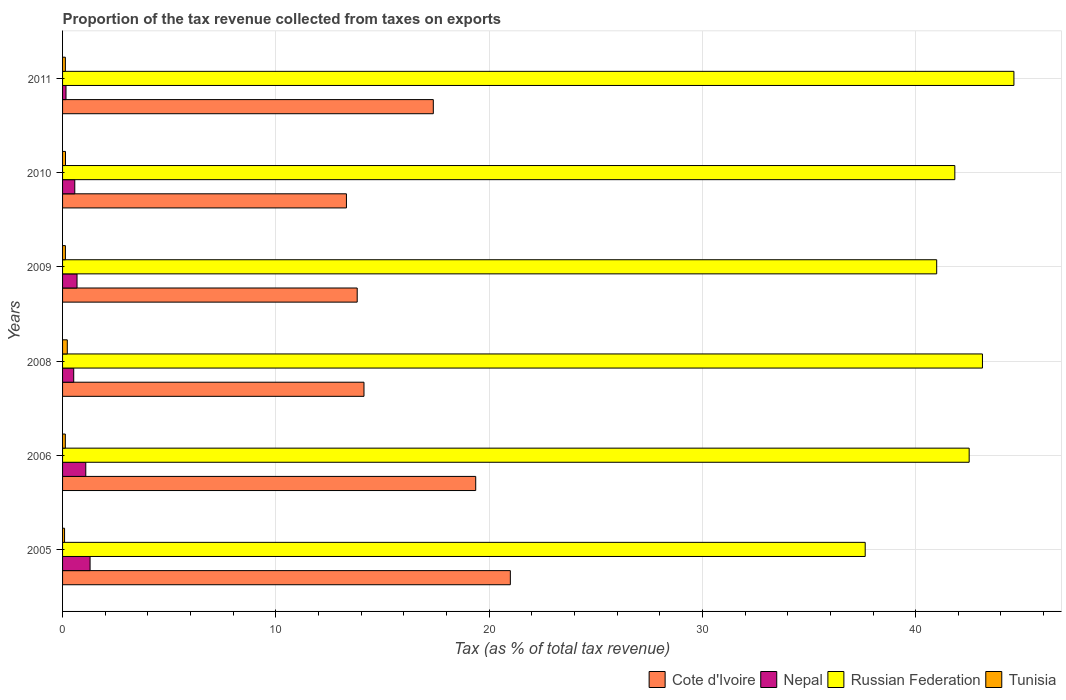How many different coloured bars are there?
Your answer should be compact. 4. How many groups of bars are there?
Your answer should be compact. 6. What is the label of the 3rd group of bars from the top?
Provide a succinct answer. 2009. What is the proportion of the tax revenue collected in Cote d'Ivoire in 2005?
Offer a very short reply. 21. Across all years, what is the maximum proportion of the tax revenue collected in Nepal?
Your answer should be compact. 1.29. Across all years, what is the minimum proportion of the tax revenue collected in Russian Federation?
Your answer should be compact. 37.63. What is the total proportion of the tax revenue collected in Tunisia in the graph?
Provide a short and direct response. 0.85. What is the difference between the proportion of the tax revenue collected in Russian Federation in 2005 and that in 2009?
Provide a succinct answer. -3.35. What is the difference between the proportion of the tax revenue collected in Nepal in 2005 and the proportion of the tax revenue collected in Cote d'Ivoire in 2009?
Offer a very short reply. -12.52. What is the average proportion of the tax revenue collected in Nepal per year?
Your answer should be compact. 0.72. In the year 2011, what is the difference between the proportion of the tax revenue collected in Russian Federation and proportion of the tax revenue collected in Tunisia?
Offer a terse response. 44.48. In how many years, is the proportion of the tax revenue collected in Russian Federation greater than 16 %?
Your answer should be compact. 6. What is the ratio of the proportion of the tax revenue collected in Russian Federation in 2005 to that in 2009?
Ensure brevity in your answer.  0.92. Is the proportion of the tax revenue collected in Nepal in 2008 less than that in 2011?
Make the answer very short. No. What is the difference between the highest and the second highest proportion of the tax revenue collected in Cote d'Ivoire?
Give a very brief answer. 1.62. What is the difference between the highest and the lowest proportion of the tax revenue collected in Tunisia?
Offer a very short reply. 0.13. In how many years, is the proportion of the tax revenue collected in Tunisia greater than the average proportion of the tax revenue collected in Tunisia taken over all years?
Provide a short and direct response. 1. Is it the case that in every year, the sum of the proportion of the tax revenue collected in Cote d'Ivoire and proportion of the tax revenue collected in Russian Federation is greater than the sum of proportion of the tax revenue collected in Nepal and proportion of the tax revenue collected in Tunisia?
Offer a terse response. Yes. What does the 4th bar from the top in 2010 represents?
Make the answer very short. Cote d'Ivoire. What does the 4th bar from the bottom in 2009 represents?
Make the answer very short. Tunisia. How many years are there in the graph?
Your answer should be compact. 6. What is the difference between two consecutive major ticks on the X-axis?
Keep it short and to the point. 10. Are the values on the major ticks of X-axis written in scientific E-notation?
Your response must be concise. No. Does the graph contain grids?
Give a very brief answer. Yes. What is the title of the graph?
Keep it short and to the point. Proportion of the tax revenue collected from taxes on exports. What is the label or title of the X-axis?
Make the answer very short. Tax (as % of total tax revenue). What is the Tax (as % of total tax revenue) in Cote d'Ivoire in 2005?
Your answer should be compact. 21. What is the Tax (as % of total tax revenue) in Nepal in 2005?
Offer a very short reply. 1.29. What is the Tax (as % of total tax revenue) in Russian Federation in 2005?
Your response must be concise. 37.63. What is the Tax (as % of total tax revenue) in Tunisia in 2005?
Ensure brevity in your answer.  0.09. What is the Tax (as % of total tax revenue) in Cote d'Ivoire in 2006?
Your answer should be compact. 19.37. What is the Tax (as % of total tax revenue) of Nepal in 2006?
Provide a succinct answer. 1.09. What is the Tax (as % of total tax revenue) in Russian Federation in 2006?
Your answer should be compact. 42.51. What is the Tax (as % of total tax revenue) of Tunisia in 2006?
Your response must be concise. 0.13. What is the Tax (as % of total tax revenue) of Cote d'Ivoire in 2008?
Your response must be concise. 14.13. What is the Tax (as % of total tax revenue) in Nepal in 2008?
Give a very brief answer. 0.52. What is the Tax (as % of total tax revenue) in Russian Federation in 2008?
Keep it short and to the point. 43.13. What is the Tax (as % of total tax revenue) of Tunisia in 2008?
Your response must be concise. 0.22. What is the Tax (as % of total tax revenue) in Cote d'Ivoire in 2009?
Keep it short and to the point. 13.81. What is the Tax (as % of total tax revenue) in Nepal in 2009?
Your answer should be very brief. 0.68. What is the Tax (as % of total tax revenue) in Russian Federation in 2009?
Make the answer very short. 40.99. What is the Tax (as % of total tax revenue) of Tunisia in 2009?
Keep it short and to the point. 0.13. What is the Tax (as % of total tax revenue) in Cote d'Ivoire in 2010?
Make the answer very short. 13.31. What is the Tax (as % of total tax revenue) in Nepal in 2010?
Offer a terse response. 0.57. What is the Tax (as % of total tax revenue) of Russian Federation in 2010?
Your answer should be very brief. 41.84. What is the Tax (as % of total tax revenue) in Tunisia in 2010?
Keep it short and to the point. 0.14. What is the Tax (as % of total tax revenue) of Cote d'Ivoire in 2011?
Ensure brevity in your answer.  17.38. What is the Tax (as % of total tax revenue) in Nepal in 2011?
Your answer should be very brief. 0.16. What is the Tax (as % of total tax revenue) of Russian Federation in 2011?
Ensure brevity in your answer.  44.61. What is the Tax (as % of total tax revenue) of Tunisia in 2011?
Offer a terse response. 0.13. Across all years, what is the maximum Tax (as % of total tax revenue) of Cote d'Ivoire?
Your answer should be compact. 21. Across all years, what is the maximum Tax (as % of total tax revenue) of Nepal?
Make the answer very short. 1.29. Across all years, what is the maximum Tax (as % of total tax revenue) in Russian Federation?
Your answer should be compact. 44.61. Across all years, what is the maximum Tax (as % of total tax revenue) of Tunisia?
Provide a succinct answer. 0.22. Across all years, what is the minimum Tax (as % of total tax revenue) in Cote d'Ivoire?
Give a very brief answer. 13.31. Across all years, what is the minimum Tax (as % of total tax revenue) of Nepal?
Keep it short and to the point. 0.16. Across all years, what is the minimum Tax (as % of total tax revenue) in Russian Federation?
Your response must be concise. 37.63. Across all years, what is the minimum Tax (as % of total tax revenue) of Tunisia?
Keep it short and to the point. 0.09. What is the total Tax (as % of total tax revenue) in Cote d'Ivoire in the graph?
Provide a short and direct response. 99.01. What is the total Tax (as % of total tax revenue) in Nepal in the graph?
Your response must be concise. 4.31. What is the total Tax (as % of total tax revenue) of Russian Federation in the graph?
Provide a short and direct response. 250.71. What is the total Tax (as % of total tax revenue) of Tunisia in the graph?
Give a very brief answer. 0.85. What is the difference between the Tax (as % of total tax revenue) in Cote d'Ivoire in 2005 and that in 2006?
Provide a succinct answer. 1.62. What is the difference between the Tax (as % of total tax revenue) in Nepal in 2005 and that in 2006?
Ensure brevity in your answer.  0.2. What is the difference between the Tax (as % of total tax revenue) in Russian Federation in 2005 and that in 2006?
Keep it short and to the point. -4.87. What is the difference between the Tax (as % of total tax revenue) in Tunisia in 2005 and that in 2006?
Your answer should be very brief. -0.04. What is the difference between the Tax (as % of total tax revenue) of Cote d'Ivoire in 2005 and that in 2008?
Offer a terse response. 6.86. What is the difference between the Tax (as % of total tax revenue) in Nepal in 2005 and that in 2008?
Keep it short and to the point. 0.77. What is the difference between the Tax (as % of total tax revenue) in Russian Federation in 2005 and that in 2008?
Make the answer very short. -5.5. What is the difference between the Tax (as % of total tax revenue) in Tunisia in 2005 and that in 2008?
Offer a very short reply. -0.13. What is the difference between the Tax (as % of total tax revenue) of Cote d'Ivoire in 2005 and that in 2009?
Make the answer very short. 7.18. What is the difference between the Tax (as % of total tax revenue) of Nepal in 2005 and that in 2009?
Your response must be concise. 0.61. What is the difference between the Tax (as % of total tax revenue) in Russian Federation in 2005 and that in 2009?
Offer a very short reply. -3.35. What is the difference between the Tax (as % of total tax revenue) of Tunisia in 2005 and that in 2009?
Provide a short and direct response. -0.04. What is the difference between the Tax (as % of total tax revenue) of Cote d'Ivoire in 2005 and that in 2010?
Your response must be concise. 7.69. What is the difference between the Tax (as % of total tax revenue) in Nepal in 2005 and that in 2010?
Offer a terse response. 0.72. What is the difference between the Tax (as % of total tax revenue) of Russian Federation in 2005 and that in 2010?
Your answer should be compact. -4.2. What is the difference between the Tax (as % of total tax revenue) of Tunisia in 2005 and that in 2010?
Provide a succinct answer. -0.04. What is the difference between the Tax (as % of total tax revenue) of Cote d'Ivoire in 2005 and that in 2011?
Provide a short and direct response. 3.61. What is the difference between the Tax (as % of total tax revenue) in Nepal in 2005 and that in 2011?
Your answer should be very brief. 1.13. What is the difference between the Tax (as % of total tax revenue) in Russian Federation in 2005 and that in 2011?
Give a very brief answer. -6.97. What is the difference between the Tax (as % of total tax revenue) in Tunisia in 2005 and that in 2011?
Offer a very short reply. -0.04. What is the difference between the Tax (as % of total tax revenue) in Cote d'Ivoire in 2006 and that in 2008?
Provide a succinct answer. 5.24. What is the difference between the Tax (as % of total tax revenue) of Nepal in 2006 and that in 2008?
Make the answer very short. 0.57. What is the difference between the Tax (as % of total tax revenue) of Russian Federation in 2006 and that in 2008?
Ensure brevity in your answer.  -0.62. What is the difference between the Tax (as % of total tax revenue) of Tunisia in 2006 and that in 2008?
Provide a short and direct response. -0.09. What is the difference between the Tax (as % of total tax revenue) of Cote d'Ivoire in 2006 and that in 2009?
Give a very brief answer. 5.56. What is the difference between the Tax (as % of total tax revenue) of Nepal in 2006 and that in 2009?
Provide a short and direct response. 0.41. What is the difference between the Tax (as % of total tax revenue) in Russian Federation in 2006 and that in 2009?
Make the answer very short. 1.52. What is the difference between the Tax (as % of total tax revenue) of Tunisia in 2006 and that in 2009?
Your response must be concise. -0. What is the difference between the Tax (as % of total tax revenue) in Cote d'Ivoire in 2006 and that in 2010?
Your response must be concise. 6.06. What is the difference between the Tax (as % of total tax revenue) of Nepal in 2006 and that in 2010?
Provide a succinct answer. 0.52. What is the difference between the Tax (as % of total tax revenue) in Russian Federation in 2006 and that in 2010?
Your response must be concise. 0.67. What is the difference between the Tax (as % of total tax revenue) in Tunisia in 2006 and that in 2010?
Offer a very short reply. -0.01. What is the difference between the Tax (as % of total tax revenue) in Cote d'Ivoire in 2006 and that in 2011?
Your answer should be compact. 1.99. What is the difference between the Tax (as % of total tax revenue) in Nepal in 2006 and that in 2011?
Your answer should be very brief. 0.93. What is the difference between the Tax (as % of total tax revenue) in Russian Federation in 2006 and that in 2011?
Provide a short and direct response. -2.1. What is the difference between the Tax (as % of total tax revenue) in Tunisia in 2006 and that in 2011?
Your answer should be very brief. -0. What is the difference between the Tax (as % of total tax revenue) in Cote d'Ivoire in 2008 and that in 2009?
Provide a short and direct response. 0.32. What is the difference between the Tax (as % of total tax revenue) in Nepal in 2008 and that in 2009?
Make the answer very short. -0.15. What is the difference between the Tax (as % of total tax revenue) of Russian Federation in 2008 and that in 2009?
Provide a succinct answer. 2.15. What is the difference between the Tax (as % of total tax revenue) in Tunisia in 2008 and that in 2009?
Offer a very short reply. 0.09. What is the difference between the Tax (as % of total tax revenue) of Cote d'Ivoire in 2008 and that in 2010?
Provide a short and direct response. 0.82. What is the difference between the Tax (as % of total tax revenue) in Nepal in 2008 and that in 2010?
Give a very brief answer. -0.05. What is the difference between the Tax (as % of total tax revenue) in Russian Federation in 2008 and that in 2010?
Make the answer very short. 1.3. What is the difference between the Tax (as % of total tax revenue) in Tunisia in 2008 and that in 2010?
Keep it short and to the point. 0.08. What is the difference between the Tax (as % of total tax revenue) in Cote d'Ivoire in 2008 and that in 2011?
Your response must be concise. -3.25. What is the difference between the Tax (as % of total tax revenue) of Nepal in 2008 and that in 2011?
Your response must be concise. 0.36. What is the difference between the Tax (as % of total tax revenue) in Russian Federation in 2008 and that in 2011?
Provide a short and direct response. -1.48. What is the difference between the Tax (as % of total tax revenue) in Tunisia in 2008 and that in 2011?
Your response must be concise. 0.09. What is the difference between the Tax (as % of total tax revenue) in Cote d'Ivoire in 2009 and that in 2010?
Ensure brevity in your answer.  0.5. What is the difference between the Tax (as % of total tax revenue) of Nepal in 2009 and that in 2010?
Make the answer very short. 0.11. What is the difference between the Tax (as % of total tax revenue) of Russian Federation in 2009 and that in 2010?
Provide a succinct answer. -0.85. What is the difference between the Tax (as % of total tax revenue) in Tunisia in 2009 and that in 2010?
Your answer should be very brief. -0. What is the difference between the Tax (as % of total tax revenue) in Cote d'Ivoire in 2009 and that in 2011?
Offer a very short reply. -3.57. What is the difference between the Tax (as % of total tax revenue) of Nepal in 2009 and that in 2011?
Offer a terse response. 0.52. What is the difference between the Tax (as % of total tax revenue) of Russian Federation in 2009 and that in 2011?
Keep it short and to the point. -3.62. What is the difference between the Tax (as % of total tax revenue) of Tunisia in 2009 and that in 2011?
Keep it short and to the point. 0. What is the difference between the Tax (as % of total tax revenue) of Cote d'Ivoire in 2010 and that in 2011?
Give a very brief answer. -4.07. What is the difference between the Tax (as % of total tax revenue) of Nepal in 2010 and that in 2011?
Your response must be concise. 0.41. What is the difference between the Tax (as % of total tax revenue) in Russian Federation in 2010 and that in 2011?
Provide a succinct answer. -2.77. What is the difference between the Tax (as % of total tax revenue) in Tunisia in 2010 and that in 2011?
Provide a short and direct response. 0.01. What is the difference between the Tax (as % of total tax revenue) of Cote d'Ivoire in 2005 and the Tax (as % of total tax revenue) of Nepal in 2006?
Give a very brief answer. 19.91. What is the difference between the Tax (as % of total tax revenue) in Cote d'Ivoire in 2005 and the Tax (as % of total tax revenue) in Russian Federation in 2006?
Provide a short and direct response. -21.51. What is the difference between the Tax (as % of total tax revenue) in Cote d'Ivoire in 2005 and the Tax (as % of total tax revenue) in Tunisia in 2006?
Provide a succinct answer. 20.87. What is the difference between the Tax (as % of total tax revenue) in Nepal in 2005 and the Tax (as % of total tax revenue) in Russian Federation in 2006?
Provide a short and direct response. -41.22. What is the difference between the Tax (as % of total tax revenue) of Nepal in 2005 and the Tax (as % of total tax revenue) of Tunisia in 2006?
Ensure brevity in your answer.  1.16. What is the difference between the Tax (as % of total tax revenue) of Russian Federation in 2005 and the Tax (as % of total tax revenue) of Tunisia in 2006?
Your answer should be very brief. 37.51. What is the difference between the Tax (as % of total tax revenue) in Cote d'Ivoire in 2005 and the Tax (as % of total tax revenue) in Nepal in 2008?
Your answer should be compact. 20.47. What is the difference between the Tax (as % of total tax revenue) in Cote d'Ivoire in 2005 and the Tax (as % of total tax revenue) in Russian Federation in 2008?
Provide a succinct answer. -22.14. What is the difference between the Tax (as % of total tax revenue) in Cote d'Ivoire in 2005 and the Tax (as % of total tax revenue) in Tunisia in 2008?
Your response must be concise. 20.77. What is the difference between the Tax (as % of total tax revenue) in Nepal in 2005 and the Tax (as % of total tax revenue) in Russian Federation in 2008?
Ensure brevity in your answer.  -41.84. What is the difference between the Tax (as % of total tax revenue) of Nepal in 2005 and the Tax (as % of total tax revenue) of Tunisia in 2008?
Your answer should be very brief. 1.07. What is the difference between the Tax (as % of total tax revenue) of Russian Federation in 2005 and the Tax (as % of total tax revenue) of Tunisia in 2008?
Provide a short and direct response. 37.41. What is the difference between the Tax (as % of total tax revenue) in Cote d'Ivoire in 2005 and the Tax (as % of total tax revenue) in Nepal in 2009?
Make the answer very short. 20.32. What is the difference between the Tax (as % of total tax revenue) of Cote d'Ivoire in 2005 and the Tax (as % of total tax revenue) of Russian Federation in 2009?
Keep it short and to the point. -19.99. What is the difference between the Tax (as % of total tax revenue) in Cote d'Ivoire in 2005 and the Tax (as % of total tax revenue) in Tunisia in 2009?
Offer a very short reply. 20.86. What is the difference between the Tax (as % of total tax revenue) of Nepal in 2005 and the Tax (as % of total tax revenue) of Russian Federation in 2009?
Offer a terse response. -39.7. What is the difference between the Tax (as % of total tax revenue) in Nepal in 2005 and the Tax (as % of total tax revenue) in Tunisia in 2009?
Offer a terse response. 1.16. What is the difference between the Tax (as % of total tax revenue) in Russian Federation in 2005 and the Tax (as % of total tax revenue) in Tunisia in 2009?
Give a very brief answer. 37.5. What is the difference between the Tax (as % of total tax revenue) in Cote d'Ivoire in 2005 and the Tax (as % of total tax revenue) in Nepal in 2010?
Ensure brevity in your answer.  20.42. What is the difference between the Tax (as % of total tax revenue) of Cote d'Ivoire in 2005 and the Tax (as % of total tax revenue) of Russian Federation in 2010?
Your answer should be very brief. -20.84. What is the difference between the Tax (as % of total tax revenue) in Cote d'Ivoire in 2005 and the Tax (as % of total tax revenue) in Tunisia in 2010?
Your response must be concise. 20.86. What is the difference between the Tax (as % of total tax revenue) of Nepal in 2005 and the Tax (as % of total tax revenue) of Russian Federation in 2010?
Offer a very short reply. -40.55. What is the difference between the Tax (as % of total tax revenue) in Nepal in 2005 and the Tax (as % of total tax revenue) in Tunisia in 2010?
Give a very brief answer. 1.15. What is the difference between the Tax (as % of total tax revenue) of Russian Federation in 2005 and the Tax (as % of total tax revenue) of Tunisia in 2010?
Offer a very short reply. 37.5. What is the difference between the Tax (as % of total tax revenue) in Cote d'Ivoire in 2005 and the Tax (as % of total tax revenue) in Nepal in 2011?
Your answer should be compact. 20.83. What is the difference between the Tax (as % of total tax revenue) of Cote d'Ivoire in 2005 and the Tax (as % of total tax revenue) of Russian Federation in 2011?
Give a very brief answer. -23.61. What is the difference between the Tax (as % of total tax revenue) in Cote d'Ivoire in 2005 and the Tax (as % of total tax revenue) in Tunisia in 2011?
Your response must be concise. 20.86. What is the difference between the Tax (as % of total tax revenue) in Nepal in 2005 and the Tax (as % of total tax revenue) in Russian Federation in 2011?
Offer a terse response. -43.32. What is the difference between the Tax (as % of total tax revenue) in Nepal in 2005 and the Tax (as % of total tax revenue) in Tunisia in 2011?
Provide a succinct answer. 1.16. What is the difference between the Tax (as % of total tax revenue) in Russian Federation in 2005 and the Tax (as % of total tax revenue) in Tunisia in 2011?
Keep it short and to the point. 37.5. What is the difference between the Tax (as % of total tax revenue) in Cote d'Ivoire in 2006 and the Tax (as % of total tax revenue) in Nepal in 2008?
Offer a very short reply. 18.85. What is the difference between the Tax (as % of total tax revenue) in Cote d'Ivoire in 2006 and the Tax (as % of total tax revenue) in Russian Federation in 2008?
Offer a terse response. -23.76. What is the difference between the Tax (as % of total tax revenue) in Cote d'Ivoire in 2006 and the Tax (as % of total tax revenue) in Tunisia in 2008?
Provide a succinct answer. 19.15. What is the difference between the Tax (as % of total tax revenue) of Nepal in 2006 and the Tax (as % of total tax revenue) of Russian Federation in 2008?
Keep it short and to the point. -42.04. What is the difference between the Tax (as % of total tax revenue) of Nepal in 2006 and the Tax (as % of total tax revenue) of Tunisia in 2008?
Your answer should be very brief. 0.87. What is the difference between the Tax (as % of total tax revenue) in Russian Federation in 2006 and the Tax (as % of total tax revenue) in Tunisia in 2008?
Make the answer very short. 42.29. What is the difference between the Tax (as % of total tax revenue) of Cote d'Ivoire in 2006 and the Tax (as % of total tax revenue) of Nepal in 2009?
Provide a succinct answer. 18.69. What is the difference between the Tax (as % of total tax revenue) of Cote d'Ivoire in 2006 and the Tax (as % of total tax revenue) of Russian Federation in 2009?
Your response must be concise. -21.61. What is the difference between the Tax (as % of total tax revenue) in Cote d'Ivoire in 2006 and the Tax (as % of total tax revenue) in Tunisia in 2009?
Ensure brevity in your answer.  19.24. What is the difference between the Tax (as % of total tax revenue) of Nepal in 2006 and the Tax (as % of total tax revenue) of Russian Federation in 2009?
Ensure brevity in your answer.  -39.9. What is the difference between the Tax (as % of total tax revenue) in Nepal in 2006 and the Tax (as % of total tax revenue) in Tunisia in 2009?
Keep it short and to the point. 0.96. What is the difference between the Tax (as % of total tax revenue) in Russian Federation in 2006 and the Tax (as % of total tax revenue) in Tunisia in 2009?
Offer a very short reply. 42.38. What is the difference between the Tax (as % of total tax revenue) of Cote d'Ivoire in 2006 and the Tax (as % of total tax revenue) of Nepal in 2010?
Offer a very short reply. 18.8. What is the difference between the Tax (as % of total tax revenue) of Cote d'Ivoire in 2006 and the Tax (as % of total tax revenue) of Russian Federation in 2010?
Ensure brevity in your answer.  -22.46. What is the difference between the Tax (as % of total tax revenue) in Cote d'Ivoire in 2006 and the Tax (as % of total tax revenue) in Tunisia in 2010?
Offer a terse response. 19.23. What is the difference between the Tax (as % of total tax revenue) in Nepal in 2006 and the Tax (as % of total tax revenue) in Russian Federation in 2010?
Provide a short and direct response. -40.75. What is the difference between the Tax (as % of total tax revenue) in Nepal in 2006 and the Tax (as % of total tax revenue) in Tunisia in 2010?
Make the answer very short. 0.95. What is the difference between the Tax (as % of total tax revenue) of Russian Federation in 2006 and the Tax (as % of total tax revenue) of Tunisia in 2010?
Your response must be concise. 42.37. What is the difference between the Tax (as % of total tax revenue) of Cote d'Ivoire in 2006 and the Tax (as % of total tax revenue) of Nepal in 2011?
Offer a very short reply. 19.21. What is the difference between the Tax (as % of total tax revenue) of Cote d'Ivoire in 2006 and the Tax (as % of total tax revenue) of Russian Federation in 2011?
Offer a terse response. -25.24. What is the difference between the Tax (as % of total tax revenue) in Cote d'Ivoire in 2006 and the Tax (as % of total tax revenue) in Tunisia in 2011?
Provide a succinct answer. 19.24. What is the difference between the Tax (as % of total tax revenue) in Nepal in 2006 and the Tax (as % of total tax revenue) in Russian Federation in 2011?
Make the answer very short. -43.52. What is the difference between the Tax (as % of total tax revenue) of Nepal in 2006 and the Tax (as % of total tax revenue) of Tunisia in 2011?
Your answer should be very brief. 0.96. What is the difference between the Tax (as % of total tax revenue) in Russian Federation in 2006 and the Tax (as % of total tax revenue) in Tunisia in 2011?
Offer a terse response. 42.38. What is the difference between the Tax (as % of total tax revenue) of Cote d'Ivoire in 2008 and the Tax (as % of total tax revenue) of Nepal in 2009?
Give a very brief answer. 13.46. What is the difference between the Tax (as % of total tax revenue) in Cote d'Ivoire in 2008 and the Tax (as % of total tax revenue) in Russian Federation in 2009?
Your answer should be compact. -26.85. What is the difference between the Tax (as % of total tax revenue) of Cote d'Ivoire in 2008 and the Tax (as % of total tax revenue) of Tunisia in 2009?
Offer a terse response. 14. What is the difference between the Tax (as % of total tax revenue) of Nepal in 2008 and the Tax (as % of total tax revenue) of Russian Federation in 2009?
Provide a short and direct response. -40.46. What is the difference between the Tax (as % of total tax revenue) in Nepal in 2008 and the Tax (as % of total tax revenue) in Tunisia in 2009?
Offer a very short reply. 0.39. What is the difference between the Tax (as % of total tax revenue) of Russian Federation in 2008 and the Tax (as % of total tax revenue) of Tunisia in 2009?
Offer a very short reply. 43. What is the difference between the Tax (as % of total tax revenue) in Cote d'Ivoire in 2008 and the Tax (as % of total tax revenue) in Nepal in 2010?
Provide a short and direct response. 13.56. What is the difference between the Tax (as % of total tax revenue) in Cote d'Ivoire in 2008 and the Tax (as % of total tax revenue) in Russian Federation in 2010?
Offer a terse response. -27.7. What is the difference between the Tax (as % of total tax revenue) in Cote d'Ivoire in 2008 and the Tax (as % of total tax revenue) in Tunisia in 2010?
Give a very brief answer. 14. What is the difference between the Tax (as % of total tax revenue) of Nepal in 2008 and the Tax (as % of total tax revenue) of Russian Federation in 2010?
Offer a terse response. -41.31. What is the difference between the Tax (as % of total tax revenue) in Nepal in 2008 and the Tax (as % of total tax revenue) in Tunisia in 2010?
Keep it short and to the point. 0.39. What is the difference between the Tax (as % of total tax revenue) of Russian Federation in 2008 and the Tax (as % of total tax revenue) of Tunisia in 2010?
Your answer should be compact. 42.99. What is the difference between the Tax (as % of total tax revenue) of Cote d'Ivoire in 2008 and the Tax (as % of total tax revenue) of Nepal in 2011?
Offer a terse response. 13.97. What is the difference between the Tax (as % of total tax revenue) of Cote d'Ivoire in 2008 and the Tax (as % of total tax revenue) of Russian Federation in 2011?
Provide a short and direct response. -30.47. What is the difference between the Tax (as % of total tax revenue) of Cote d'Ivoire in 2008 and the Tax (as % of total tax revenue) of Tunisia in 2011?
Make the answer very short. 14. What is the difference between the Tax (as % of total tax revenue) in Nepal in 2008 and the Tax (as % of total tax revenue) in Russian Federation in 2011?
Offer a terse response. -44.08. What is the difference between the Tax (as % of total tax revenue) of Nepal in 2008 and the Tax (as % of total tax revenue) of Tunisia in 2011?
Provide a succinct answer. 0.39. What is the difference between the Tax (as % of total tax revenue) of Russian Federation in 2008 and the Tax (as % of total tax revenue) of Tunisia in 2011?
Ensure brevity in your answer.  43. What is the difference between the Tax (as % of total tax revenue) of Cote d'Ivoire in 2009 and the Tax (as % of total tax revenue) of Nepal in 2010?
Provide a short and direct response. 13.24. What is the difference between the Tax (as % of total tax revenue) of Cote d'Ivoire in 2009 and the Tax (as % of total tax revenue) of Russian Federation in 2010?
Your response must be concise. -28.02. What is the difference between the Tax (as % of total tax revenue) in Cote d'Ivoire in 2009 and the Tax (as % of total tax revenue) in Tunisia in 2010?
Offer a terse response. 13.68. What is the difference between the Tax (as % of total tax revenue) of Nepal in 2009 and the Tax (as % of total tax revenue) of Russian Federation in 2010?
Your answer should be very brief. -41.16. What is the difference between the Tax (as % of total tax revenue) of Nepal in 2009 and the Tax (as % of total tax revenue) of Tunisia in 2010?
Ensure brevity in your answer.  0.54. What is the difference between the Tax (as % of total tax revenue) of Russian Federation in 2009 and the Tax (as % of total tax revenue) of Tunisia in 2010?
Your answer should be very brief. 40.85. What is the difference between the Tax (as % of total tax revenue) of Cote d'Ivoire in 2009 and the Tax (as % of total tax revenue) of Nepal in 2011?
Provide a succinct answer. 13.65. What is the difference between the Tax (as % of total tax revenue) of Cote d'Ivoire in 2009 and the Tax (as % of total tax revenue) of Russian Federation in 2011?
Ensure brevity in your answer.  -30.79. What is the difference between the Tax (as % of total tax revenue) in Cote d'Ivoire in 2009 and the Tax (as % of total tax revenue) in Tunisia in 2011?
Give a very brief answer. 13.68. What is the difference between the Tax (as % of total tax revenue) in Nepal in 2009 and the Tax (as % of total tax revenue) in Russian Federation in 2011?
Ensure brevity in your answer.  -43.93. What is the difference between the Tax (as % of total tax revenue) of Nepal in 2009 and the Tax (as % of total tax revenue) of Tunisia in 2011?
Your answer should be compact. 0.55. What is the difference between the Tax (as % of total tax revenue) in Russian Federation in 2009 and the Tax (as % of total tax revenue) in Tunisia in 2011?
Your answer should be compact. 40.85. What is the difference between the Tax (as % of total tax revenue) in Cote d'Ivoire in 2010 and the Tax (as % of total tax revenue) in Nepal in 2011?
Ensure brevity in your answer.  13.15. What is the difference between the Tax (as % of total tax revenue) of Cote d'Ivoire in 2010 and the Tax (as % of total tax revenue) of Russian Federation in 2011?
Provide a succinct answer. -31.3. What is the difference between the Tax (as % of total tax revenue) in Cote d'Ivoire in 2010 and the Tax (as % of total tax revenue) in Tunisia in 2011?
Your answer should be very brief. 13.18. What is the difference between the Tax (as % of total tax revenue) of Nepal in 2010 and the Tax (as % of total tax revenue) of Russian Federation in 2011?
Make the answer very short. -44.03. What is the difference between the Tax (as % of total tax revenue) in Nepal in 2010 and the Tax (as % of total tax revenue) in Tunisia in 2011?
Your response must be concise. 0.44. What is the difference between the Tax (as % of total tax revenue) in Russian Federation in 2010 and the Tax (as % of total tax revenue) in Tunisia in 2011?
Keep it short and to the point. 41.71. What is the average Tax (as % of total tax revenue) in Cote d'Ivoire per year?
Your answer should be compact. 16.5. What is the average Tax (as % of total tax revenue) of Nepal per year?
Your response must be concise. 0.72. What is the average Tax (as % of total tax revenue) of Russian Federation per year?
Keep it short and to the point. 41.78. What is the average Tax (as % of total tax revenue) of Tunisia per year?
Provide a short and direct response. 0.14. In the year 2005, what is the difference between the Tax (as % of total tax revenue) of Cote d'Ivoire and Tax (as % of total tax revenue) of Nepal?
Make the answer very short. 19.71. In the year 2005, what is the difference between the Tax (as % of total tax revenue) of Cote d'Ivoire and Tax (as % of total tax revenue) of Russian Federation?
Offer a terse response. -16.64. In the year 2005, what is the difference between the Tax (as % of total tax revenue) in Cote d'Ivoire and Tax (as % of total tax revenue) in Tunisia?
Your answer should be compact. 20.9. In the year 2005, what is the difference between the Tax (as % of total tax revenue) in Nepal and Tax (as % of total tax revenue) in Russian Federation?
Keep it short and to the point. -36.34. In the year 2005, what is the difference between the Tax (as % of total tax revenue) of Nepal and Tax (as % of total tax revenue) of Tunisia?
Your answer should be compact. 1.2. In the year 2005, what is the difference between the Tax (as % of total tax revenue) of Russian Federation and Tax (as % of total tax revenue) of Tunisia?
Your answer should be very brief. 37.54. In the year 2006, what is the difference between the Tax (as % of total tax revenue) in Cote d'Ivoire and Tax (as % of total tax revenue) in Nepal?
Your response must be concise. 18.28. In the year 2006, what is the difference between the Tax (as % of total tax revenue) in Cote d'Ivoire and Tax (as % of total tax revenue) in Russian Federation?
Offer a very short reply. -23.14. In the year 2006, what is the difference between the Tax (as % of total tax revenue) in Cote d'Ivoire and Tax (as % of total tax revenue) in Tunisia?
Your answer should be compact. 19.24. In the year 2006, what is the difference between the Tax (as % of total tax revenue) in Nepal and Tax (as % of total tax revenue) in Russian Federation?
Give a very brief answer. -41.42. In the year 2006, what is the difference between the Tax (as % of total tax revenue) of Russian Federation and Tax (as % of total tax revenue) of Tunisia?
Make the answer very short. 42.38. In the year 2008, what is the difference between the Tax (as % of total tax revenue) of Cote d'Ivoire and Tax (as % of total tax revenue) of Nepal?
Your answer should be compact. 13.61. In the year 2008, what is the difference between the Tax (as % of total tax revenue) in Cote d'Ivoire and Tax (as % of total tax revenue) in Russian Federation?
Your response must be concise. -29. In the year 2008, what is the difference between the Tax (as % of total tax revenue) in Cote d'Ivoire and Tax (as % of total tax revenue) in Tunisia?
Your answer should be compact. 13.91. In the year 2008, what is the difference between the Tax (as % of total tax revenue) in Nepal and Tax (as % of total tax revenue) in Russian Federation?
Offer a very short reply. -42.61. In the year 2008, what is the difference between the Tax (as % of total tax revenue) of Nepal and Tax (as % of total tax revenue) of Tunisia?
Your answer should be very brief. 0.3. In the year 2008, what is the difference between the Tax (as % of total tax revenue) of Russian Federation and Tax (as % of total tax revenue) of Tunisia?
Ensure brevity in your answer.  42.91. In the year 2009, what is the difference between the Tax (as % of total tax revenue) in Cote d'Ivoire and Tax (as % of total tax revenue) in Nepal?
Ensure brevity in your answer.  13.14. In the year 2009, what is the difference between the Tax (as % of total tax revenue) in Cote d'Ivoire and Tax (as % of total tax revenue) in Russian Federation?
Keep it short and to the point. -27.17. In the year 2009, what is the difference between the Tax (as % of total tax revenue) in Cote d'Ivoire and Tax (as % of total tax revenue) in Tunisia?
Provide a succinct answer. 13.68. In the year 2009, what is the difference between the Tax (as % of total tax revenue) in Nepal and Tax (as % of total tax revenue) in Russian Federation?
Ensure brevity in your answer.  -40.31. In the year 2009, what is the difference between the Tax (as % of total tax revenue) in Nepal and Tax (as % of total tax revenue) in Tunisia?
Make the answer very short. 0.54. In the year 2009, what is the difference between the Tax (as % of total tax revenue) of Russian Federation and Tax (as % of total tax revenue) of Tunisia?
Provide a short and direct response. 40.85. In the year 2010, what is the difference between the Tax (as % of total tax revenue) of Cote d'Ivoire and Tax (as % of total tax revenue) of Nepal?
Provide a succinct answer. 12.74. In the year 2010, what is the difference between the Tax (as % of total tax revenue) in Cote d'Ivoire and Tax (as % of total tax revenue) in Russian Federation?
Ensure brevity in your answer.  -28.53. In the year 2010, what is the difference between the Tax (as % of total tax revenue) in Cote d'Ivoire and Tax (as % of total tax revenue) in Tunisia?
Give a very brief answer. 13.17. In the year 2010, what is the difference between the Tax (as % of total tax revenue) of Nepal and Tax (as % of total tax revenue) of Russian Federation?
Your answer should be compact. -41.26. In the year 2010, what is the difference between the Tax (as % of total tax revenue) in Nepal and Tax (as % of total tax revenue) in Tunisia?
Offer a very short reply. 0.44. In the year 2010, what is the difference between the Tax (as % of total tax revenue) of Russian Federation and Tax (as % of total tax revenue) of Tunisia?
Your response must be concise. 41.7. In the year 2011, what is the difference between the Tax (as % of total tax revenue) of Cote d'Ivoire and Tax (as % of total tax revenue) of Nepal?
Give a very brief answer. 17.22. In the year 2011, what is the difference between the Tax (as % of total tax revenue) in Cote d'Ivoire and Tax (as % of total tax revenue) in Russian Federation?
Provide a short and direct response. -27.22. In the year 2011, what is the difference between the Tax (as % of total tax revenue) of Cote d'Ivoire and Tax (as % of total tax revenue) of Tunisia?
Your response must be concise. 17.25. In the year 2011, what is the difference between the Tax (as % of total tax revenue) of Nepal and Tax (as % of total tax revenue) of Russian Federation?
Make the answer very short. -44.45. In the year 2011, what is the difference between the Tax (as % of total tax revenue) in Nepal and Tax (as % of total tax revenue) in Tunisia?
Your response must be concise. 0.03. In the year 2011, what is the difference between the Tax (as % of total tax revenue) in Russian Federation and Tax (as % of total tax revenue) in Tunisia?
Your answer should be compact. 44.48. What is the ratio of the Tax (as % of total tax revenue) of Cote d'Ivoire in 2005 to that in 2006?
Ensure brevity in your answer.  1.08. What is the ratio of the Tax (as % of total tax revenue) of Nepal in 2005 to that in 2006?
Your answer should be very brief. 1.18. What is the ratio of the Tax (as % of total tax revenue) in Russian Federation in 2005 to that in 2006?
Give a very brief answer. 0.89. What is the ratio of the Tax (as % of total tax revenue) of Tunisia in 2005 to that in 2006?
Your response must be concise. 0.72. What is the ratio of the Tax (as % of total tax revenue) of Cote d'Ivoire in 2005 to that in 2008?
Your answer should be compact. 1.49. What is the ratio of the Tax (as % of total tax revenue) of Nepal in 2005 to that in 2008?
Offer a terse response. 2.46. What is the ratio of the Tax (as % of total tax revenue) in Russian Federation in 2005 to that in 2008?
Keep it short and to the point. 0.87. What is the ratio of the Tax (as % of total tax revenue) in Tunisia in 2005 to that in 2008?
Make the answer very short. 0.42. What is the ratio of the Tax (as % of total tax revenue) in Cote d'Ivoire in 2005 to that in 2009?
Your response must be concise. 1.52. What is the ratio of the Tax (as % of total tax revenue) in Nepal in 2005 to that in 2009?
Provide a succinct answer. 1.9. What is the ratio of the Tax (as % of total tax revenue) of Russian Federation in 2005 to that in 2009?
Keep it short and to the point. 0.92. What is the ratio of the Tax (as % of total tax revenue) in Tunisia in 2005 to that in 2009?
Provide a succinct answer. 0.7. What is the ratio of the Tax (as % of total tax revenue) in Cote d'Ivoire in 2005 to that in 2010?
Offer a very short reply. 1.58. What is the ratio of the Tax (as % of total tax revenue) of Nepal in 2005 to that in 2010?
Give a very brief answer. 2.25. What is the ratio of the Tax (as % of total tax revenue) of Russian Federation in 2005 to that in 2010?
Provide a succinct answer. 0.9. What is the ratio of the Tax (as % of total tax revenue) of Tunisia in 2005 to that in 2010?
Give a very brief answer. 0.68. What is the ratio of the Tax (as % of total tax revenue) of Cote d'Ivoire in 2005 to that in 2011?
Provide a succinct answer. 1.21. What is the ratio of the Tax (as % of total tax revenue) of Nepal in 2005 to that in 2011?
Offer a very short reply. 8. What is the ratio of the Tax (as % of total tax revenue) in Russian Federation in 2005 to that in 2011?
Your answer should be very brief. 0.84. What is the ratio of the Tax (as % of total tax revenue) of Tunisia in 2005 to that in 2011?
Make the answer very short. 0.71. What is the ratio of the Tax (as % of total tax revenue) of Cote d'Ivoire in 2006 to that in 2008?
Ensure brevity in your answer.  1.37. What is the ratio of the Tax (as % of total tax revenue) in Nepal in 2006 to that in 2008?
Provide a short and direct response. 2.08. What is the ratio of the Tax (as % of total tax revenue) of Russian Federation in 2006 to that in 2008?
Your response must be concise. 0.99. What is the ratio of the Tax (as % of total tax revenue) in Tunisia in 2006 to that in 2008?
Offer a very short reply. 0.59. What is the ratio of the Tax (as % of total tax revenue) of Cote d'Ivoire in 2006 to that in 2009?
Your answer should be compact. 1.4. What is the ratio of the Tax (as % of total tax revenue) in Nepal in 2006 to that in 2009?
Ensure brevity in your answer.  1.61. What is the ratio of the Tax (as % of total tax revenue) of Russian Federation in 2006 to that in 2009?
Your answer should be compact. 1.04. What is the ratio of the Tax (as % of total tax revenue) in Tunisia in 2006 to that in 2009?
Provide a short and direct response. 0.97. What is the ratio of the Tax (as % of total tax revenue) of Cote d'Ivoire in 2006 to that in 2010?
Make the answer very short. 1.46. What is the ratio of the Tax (as % of total tax revenue) in Nepal in 2006 to that in 2010?
Your answer should be very brief. 1.9. What is the ratio of the Tax (as % of total tax revenue) of Russian Federation in 2006 to that in 2010?
Offer a very short reply. 1.02. What is the ratio of the Tax (as % of total tax revenue) in Tunisia in 2006 to that in 2010?
Provide a short and direct response. 0.94. What is the ratio of the Tax (as % of total tax revenue) in Cote d'Ivoire in 2006 to that in 2011?
Provide a short and direct response. 1.11. What is the ratio of the Tax (as % of total tax revenue) in Nepal in 2006 to that in 2011?
Your answer should be compact. 6.75. What is the ratio of the Tax (as % of total tax revenue) in Russian Federation in 2006 to that in 2011?
Your response must be concise. 0.95. What is the ratio of the Tax (as % of total tax revenue) of Tunisia in 2006 to that in 2011?
Give a very brief answer. 0.99. What is the ratio of the Tax (as % of total tax revenue) of Cote d'Ivoire in 2008 to that in 2009?
Keep it short and to the point. 1.02. What is the ratio of the Tax (as % of total tax revenue) in Nepal in 2008 to that in 2009?
Keep it short and to the point. 0.77. What is the ratio of the Tax (as % of total tax revenue) in Russian Federation in 2008 to that in 2009?
Your answer should be very brief. 1.05. What is the ratio of the Tax (as % of total tax revenue) in Tunisia in 2008 to that in 2009?
Offer a very short reply. 1.66. What is the ratio of the Tax (as % of total tax revenue) of Cote d'Ivoire in 2008 to that in 2010?
Your response must be concise. 1.06. What is the ratio of the Tax (as % of total tax revenue) of Nepal in 2008 to that in 2010?
Offer a terse response. 0.91. What is the ratio of the Tax (as % of total tax revenue) in Russian Federation in 2008 to that in 2010?
Ensure brevity in your answer.  1.03. What is the ratio of the Tax (as % of total tax revenue) of Tunisia in 2008 to that in 2010?
Give a very brief answer. 1.61. What is the ratio of the Tax (as % of total tax revenue) of Cote d'Ivoire in 2008 to that in 2011?
Ensure brevity in your answer.  0.81. What is the ratio of the Tax (as % of total tax revenue) in Nepal in 2008 to that in 2011?
Provide a short and direct response. 3.24. What is the ratio of the Tax (as % of total tax revenue) in Russian Federation in 2008 to that in 2011?
Provide a short and direct response. 0.97. What is the ratio of the Tax (as % of total tax revenue) of Tunisia in 2008 to that in 2011?
Provide a short and direct response. 1.68. What is the ratio of the Tax (as % of total tax revenue) of Cote d'Ivoire in 2009 to that in 2010?
Your answer should be compact. 1.04. What is the ratio of the Tax (as % of total tax revenue) of Nepal in 2009 to that in 2010?
Provide a succinct answer. 1.18. What is the ratio of the Tax (as % of total tax revenue) in Russian Federation in 2009 to that in 2010?
Your answer should be very brief. 0.98. What is the ratio of the Tax (as % of total tax revenue) of Tunisia in 2009 to that in 2010?
Give a very brief answer. 0.97. What is the ratio of the Tax (as % of total tax revenue) of Cote d'Ivoire in 2009 to that in 2011?
Make the answer very short. 0.79. What is the ratio of the Tax (as % of total tax revenue) of Nepal in 2009 to that in 2011?
Provide a short and direct response. 4.2. What is the ratio of the Tax (as % of total tax revenue) in Russian Federation in 2009 to that in 2011?
Offer a very short reply. 0.92. What is the ratio of the Tax (as % of total tax revenue) of Tunisia in 2009 to that in 2011?
Offer a terse response. 1.01. What is the ratio of the Tax (as % of total tax revenue) of Cote d'Ivoire in 2010 to that in 2011?
Provide a short and direct response. 0.77. What is the ratio of the Tax (as % of total tax revenue) in Nepal in 2010 to that in 2011?
Offer a very short reply. 3.55. What is the ratio of the Tax (as % of total tax revenue) in Russian Federation in 2010 to that in 2011?
Your answer should be very brief. 0.94. What is the ratio of the Tax (as % of total tax revenue) in Tunisia in 2010 to that in 2011?
Your response must be concise. 1.05. What is the difference between the highest and the second highest Tax (as % of total tax revenue) of Cote d'Ivoire?
Ensure brevity in your answer.  1.62. What is the difference between the highest and the second highest Tax (as % of total tax revenue) in Nepal?
Your answer should be very brief. 0.2. What is the difference between the highest and the second highest Tax (as % of total tax revenue) of Russian Federation?
Offer a terse response. 1.48. What is the difference between the highest and the second highest Tax (as % of total tax revenue) of Tunisia?
Ensure brevity in your answer.  0.08. What is the difference between the highest and the lowest Tax (as % of total tax revenue) of Cote d'Ivoire?
Provide a short and direct response. 7.69. What is the difference between the highest and the lowest Tax (as % of total tax revenue) in Nepal?
Offer a terse response. 1.13. What is the difference between the highest and the lowest Tax (as % of total tax revenue) in Russian Federation?
Your response must be concise. 6.97. What is the difference between the highest and the lowest Tax (as % of total tax revenue) in Tunisia?
Your response must be concise. 0.13. 